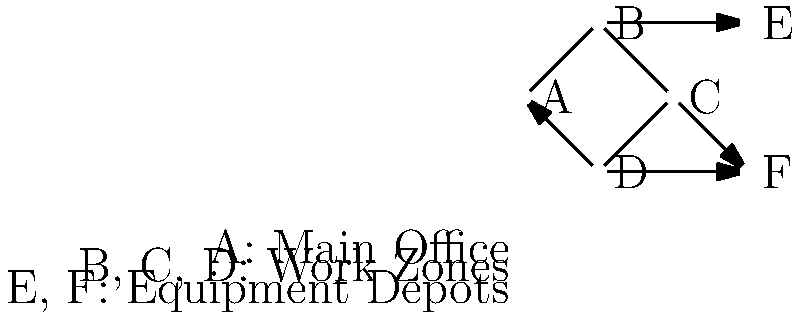In the given network topology for a construction site communication system, which node represents the critical point of failure that, if compromised, would disconnect the equipment depots (E and F) from the main office (A)? To determine the critical point of failure, we need to analyze the network topology:

1. Node A represents the main office.
2. Nodes B, C, and D represent work zones.
3. Nodes E and F represent equipment depots.
4. The network forms a ring topology (A-B-C-D-A) with additional connections to E and F.

Step-by-step analysis:
1. If node A fails, communication can still occur between other nodes.
2. If node B fails, A can still reach C, D, and F, while E becomes isolated.
3. If node C fails, A can still reach B, D, E, and F.
4. If node D fails, A can still reach B, C, and E, while F becomes isolated.
5. If node E or F fails, it only affects that specific equipment depot.

The critical point of failure is node B because:
- It's the only node connecting to equipment depot E.
- If B fails, E becomes completely disconnected from the main office (A) and all other nodes.
- While D's failure would disconnect F, there's an alternative path to F through C.

Therefore, node B is the single point of failure that, if compromised, would disconnect an equipment depot (E) from the main office (A) without any alternative routes.
Answer: Node B 